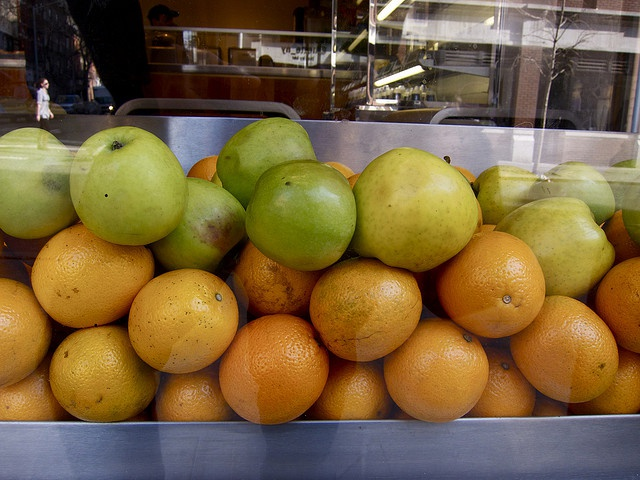Describe the objects in this image and their specific colors. I can see apple in black, olive, and khaki tones, apple in black, olive, and khaki tones, apple in black and olive tones, orange in black, olive, orange, and tan tones, and orange in black, olive, maroon, orange, and tan tones in this image. 